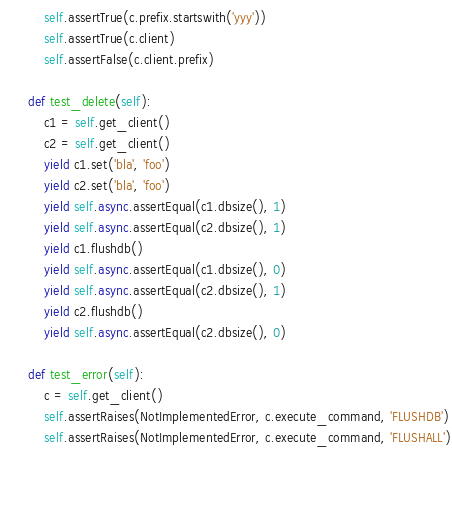<code> <loc_0><loc_0><loc_500><loc_500><_Python_>        self.assertTrue(c.prefix.startswith('yyy'))
        self.assertTrue(c.client)
        self.assertFalse(c.client.prefix)
        
    def test_delete(self):
        c1 = self.get_client()
        c2 = self.get_client()
        yield c1.set('bla', 'foo')
        yield c2.set('bla', 'foo')
        yield self.async.assertEqual(c1.dbsize(), 1)
        yield self.async.assertEqual(c2.dbsize(), 1)
        yield c1.flushdb()
        yield self.async.assertEqual(c1.dbsize(), 0)
        yield self.async.assertEqual(c2.dbsize(), 1)
        yield c2.flushdb()
        yield self.async.assertEqual(c2.dbsize(), 0)
        
    def test_error(self):
        c = self.get_client()
        self.assertRaises(NotImplementedError, c.execute_command, 'FLUSHDB')
        self.assertRaises(NotImplementedError, c.execute_command, 'FLUSHALL')
        
        
    </code> 